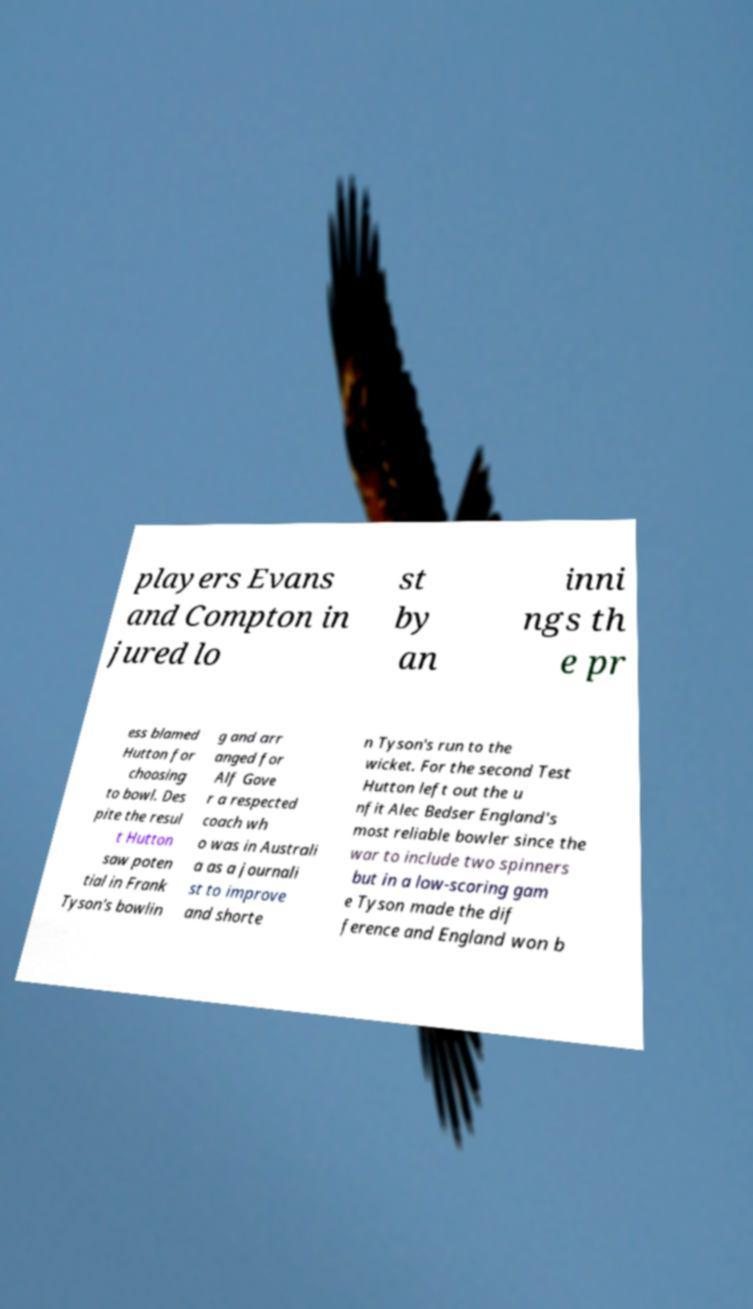There's text embedded in this image that I need extracted. Can you transcribe it verbatim? players Evans and Compton in jured lo st by an inni ngs th e pr ess blamed Hutton for choosing to bowl. Des pite the resul t Hutton saw poten tial in Frank Tyson's bowlin g and arr anged for Alf Gove r a respected coach wh o was in Australi a as a journali st to improve and shorte n Tyson's run to the wicket. For the second Test Hutton left out the u nfit Alec Bedser England's most reliable bowler since the war to include two spinners but in a low-scoring gam e Tyson made the dif ference and England won b 